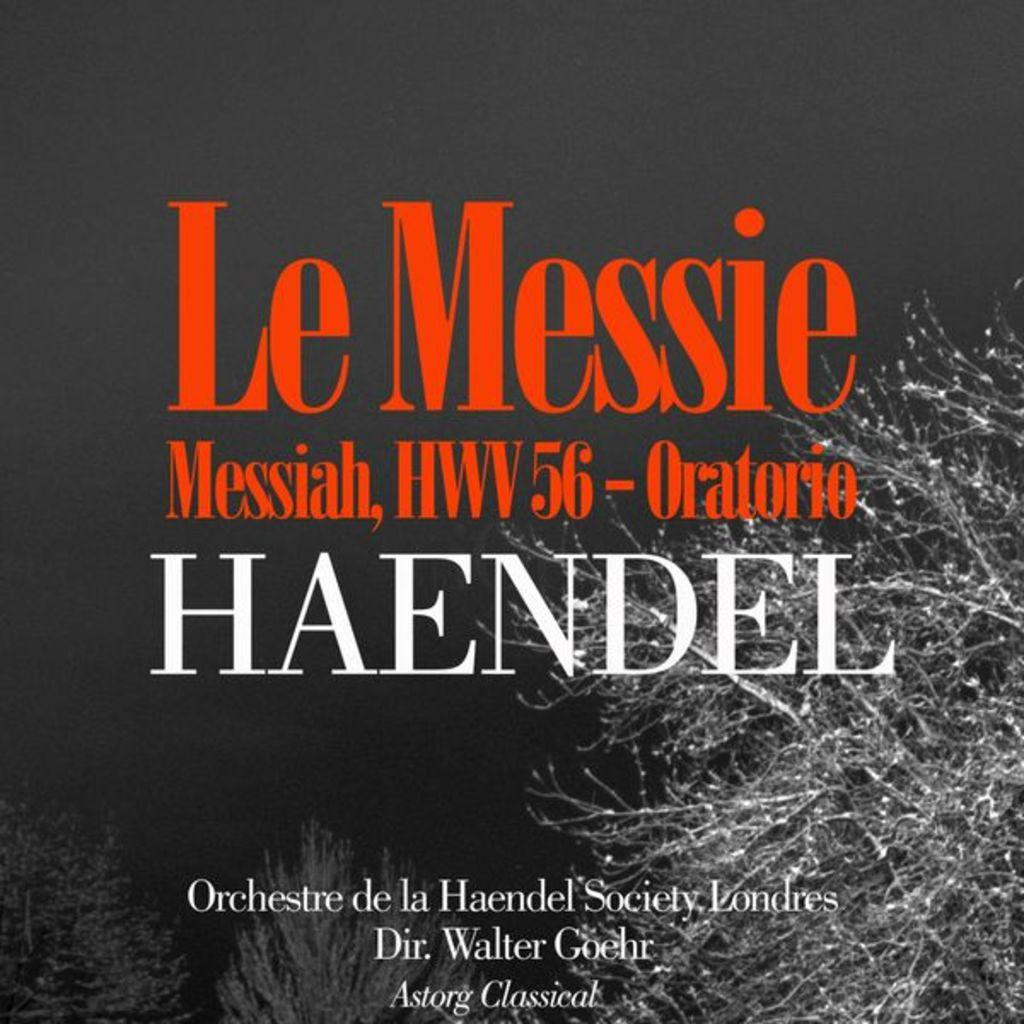What is the main subject in the center of the image? There is a poster in the center of the image. What word can be seen on the poster? The word "handle" is written on the poster. Can you see a man reading a book about a fictional volcano in the image? There is no man, book, or volcano present in the image; it only features a poster with the word "handle" on it. 